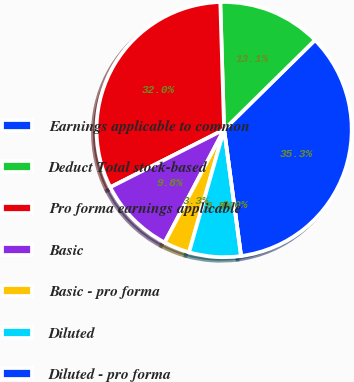<chart> <loc_0><loc_0><loc_500><loc_500><pie_chart><fcel>Earnings applicable to common<fcel>Deduct Total stock-based<fcel>Pro forma earnings applicable<fcel>Basic<fcel>Basic - pro forma<fcel>Diluted<fcel>Diluted - pro forma<nl><fcel>35.26%<fcel>13.1%<fcel>31.99%<fcel>9.83%<fcel>3.28%<fcel>6.55%<fcel>0.0%<nl></chart> 